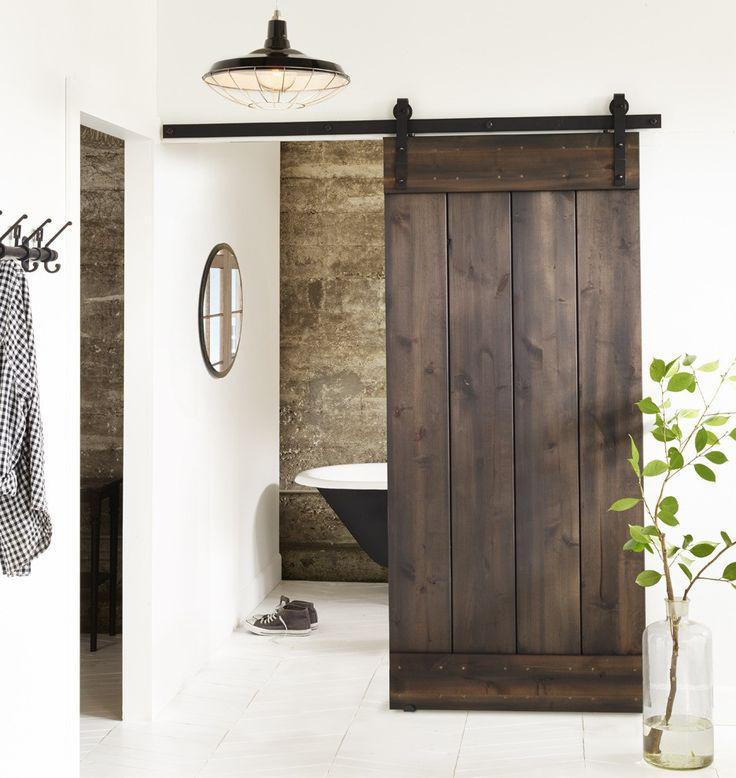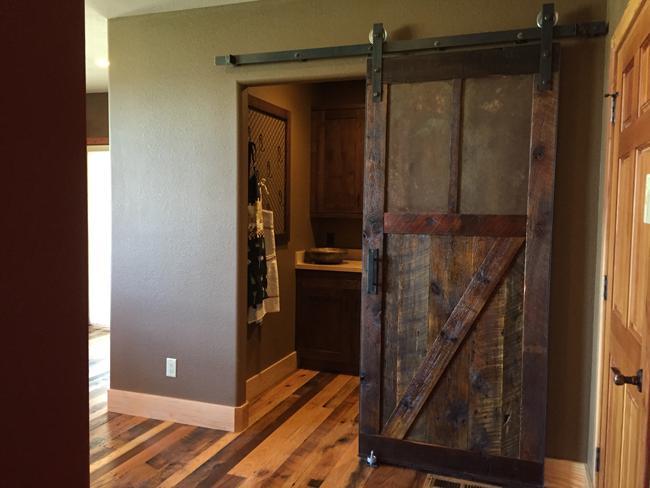The first image is the image on the left, the second image is the image on the right. Analyze the images presented: Is the assertion "One image shows a two-paneled barn door with angled wood trim and no windows." valid? Answer yes or no. No. 